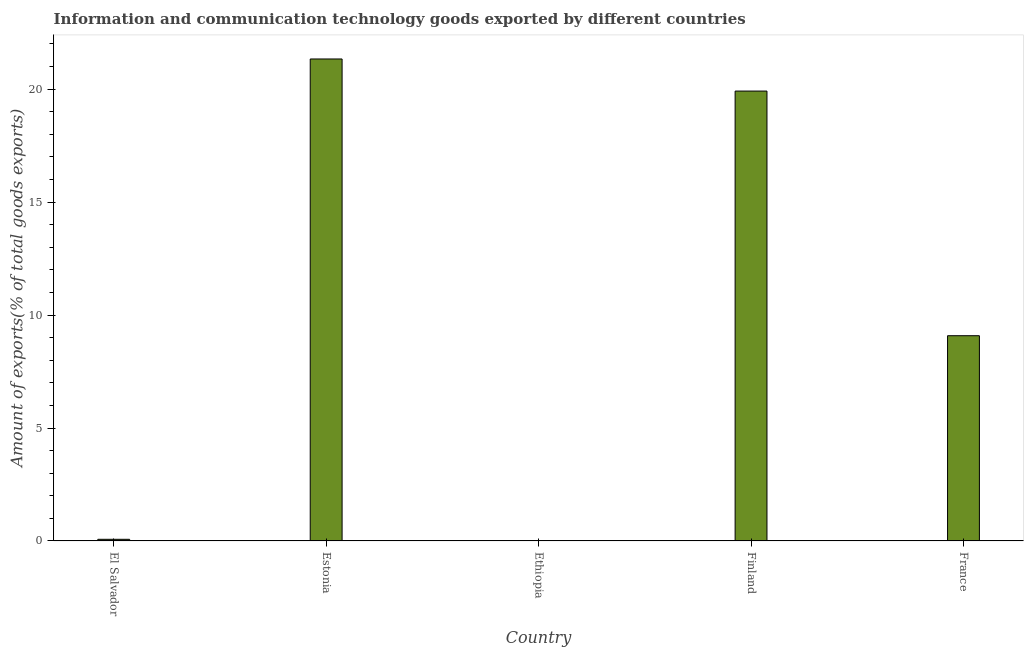Does the graph contain grids?
Keep it short and to the point. No. What is the title of the graph?
Make the answer very short. Information and communication technology goods exported by different countries. What is the label or title of the Y-axis?
Keep it short and to the point. Amount of exports(% of total goods exports). What is the amount of ict goods exports in Finland?
Provide a succinct answer. 19.91. Across all countries, what is the maximum amount of ict goods exports?
Provide a succinct answer. 21.33. Across all countries, what is the minimum amount of ict goods exports?
Give a very brief answer. 0.01. In which country was the amount of ict goods exports maximum?
Your answer should be very brief. Estonia. In which country was the amount of ict goods exports minimum?
Make the answer very short. Ethiopia. What is the sum of the amount of ict goods exports?
Your answer should be very brief. 50.41. What is the difference between the amount of ict goods exports in Ethiopia and Finland?
Provide a short and direct response. -19.9. What is the average amount of ict goods exports per country?
Offer a very short reply. 10.08. What is the median amount of ict goods exports?
Your answer should be compact. 9.08. What is the ratio of the amount of ict goods exports in El Salvador to that in Ethiopia?
Your answer should be very brief. 7.68. Is the amount of ict goods exports in Ethiopia less than that in Finland?
Provide a succinct answer. Yes. What is the difference between the highest and the second highest amount of ict goods exports?
Your response must be concise. 1.42. Is the sum of the amount of ict goods exports in Estonia and Ethiopia greater than the maximum amount of ict goods exports across all countries?
Your response must be concise. Yes. What is the difference between the highest and the lowest amount of ict goods exports?
Keep it short and to the point. 21.32. How many bars are there?
Offer a very short reply. 5. How many countries are there in the graph?
Offer a terse response. 5. What is the difference between two consecutive major ticks on the Y-axis?
Offer a terse response. 5. Are the values on the major ticks of Y-axis written in scientific E-notation?
Make the answer very short. No. What is the Amount of exports(% of total goods exports) in El Salvador?
Your answer should be very brief. 0.07. What is the Amount of exports(% of total goods exports) in Estonia?
Your answer should be compact. 21.33. What is the Amount of exports(% of total goods exports) in Ethiopia?
Keep it short and to the point. 0.01. What is the Amount of exports(% of total goods exports) in Finland?
Provide a short and direct response. 19.91. What is the Amount of exports(% of total goods exports) of France?
Keep it short and to the point. 9.08. What is the difference between the Amount of exports(% of total goods exports) in El Salvador and Estonia?
Make the answer very short. -21.26. What is the difference between the Amount of exports(% of total goods exports) in El Salvador and Ethiopia?
Provide a succinct answer. 0.06. What is the difference between the Amount of exports(% of total goods exports) in El Salvador and Finland?
Your response must be concise. -19.84. What is the difference between the Amount of exports(% of total goods exports) in El Salvador and France?
Your response must be concise. -9.01. What is the difference between the Amount of exports(% of total goods exports) in Estonia and Ethiopia?
Keep it short and to the point. 21.32. What is the difference between the Amount of exports(% of total goods exports) in Estonia and Finland?
Make the answer very short. 1.42. What is the difference between the Amount of exports(% of total goods exports) in Estonia and France?
Your response must be concise. 12.25. What is the difference between the Amount of exports(% of total goods exports) in Ethiopia and Finland?
Provide a short and direct response. -19.9. What is the difference between the Amount of exports(% of total goods exports) in Ethiopia and France?
Give a very brief answer. -9.08. What is the difference between the Amount of exports(% of total goods exports) in Finland and France?
Give a very brief answer. 10.83. What is the ratio of the Amount of exports(% of total goods exports) in El Salvador to that in Estonia?
Make the answer very short. 0. What is the ratio of the Amount of exports(% of total goods exports) in El Salvador to that in Ethiopia?
Offer a very short reply. 7.68. What is the ratio of the Amount of exports(% of total goods exports) in El Salvador to that in Finland?
Ensure brevity in your answer.  0. What is the ratio of the Amount of exports(% of total goods exports) in El Salvador to that in France?
Keep it short and to the point. 0.01. What is the ratio of the Amount of exports(% of total goods exports) in Estonia to that in Ethiopia?
Provide a short and direct response. 2218.07. What is the ratio of the Amount of exports(% of total goods exports) in Estonia to that in Finland?
Ensure brevity in your answer.  1.07. What is the ratio of the Amount of exports(% of total goods exports) in Estonia to that in France?
Provide a short and direct response. 2.35. What is the ratio of the Amount of exports(% of total goods exports) in Ethiopia to that in Finland?
Make the answer very short. 0. What is the ratio of the Amount of exports(% of total goods exports) in Ethiopia to that in France?
Your answer should be very brief. 0. What is the ratio of the Amount of exports(% of total goods exports) in Finland to that in France?
Your response must be concise. 2.19. 